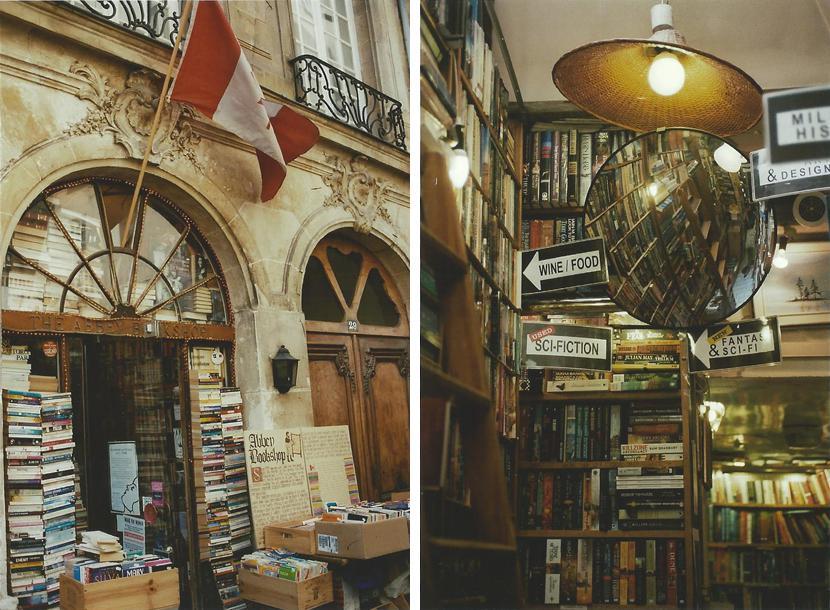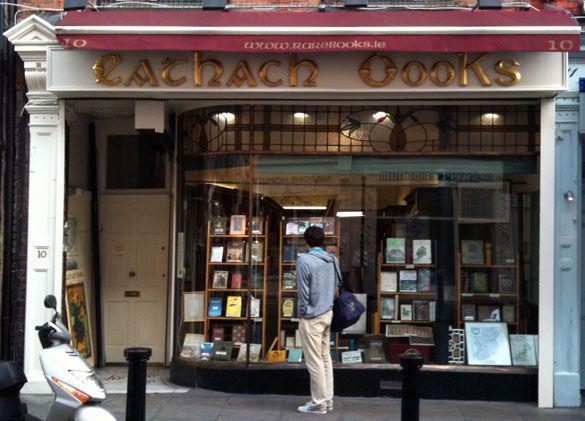The first image is the image on the left, the second image is the image on the right. Examine the images to the left and right. Is the description "There are people sitting." accurate? Answer yes or no. No. 